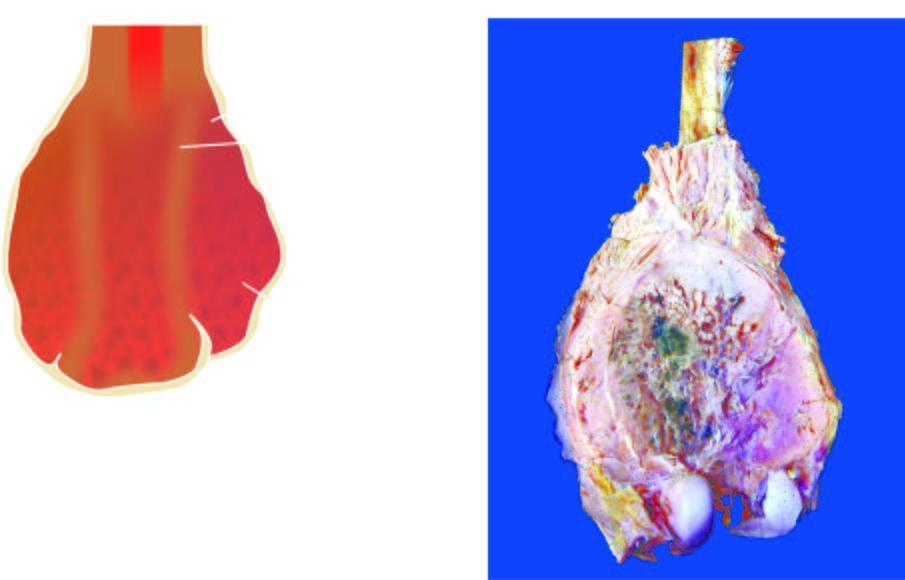s the tumour grey-white with areas of haemorrhage and necrosis?
Answer the question using a single word or phrase. Yes 